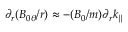<formula> <loc_0><loc_0><loc_500><loc_500>\partial _ { r } ( B _ { 0 \theta } / r ) \approx - ( B _ { 0 } / m ) \partial _ { r } k _ { \| }</formula> 